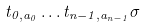Convert formula to latex. <formula><loc_0><loc_0><loc_500><loc_500>t _ { 0 , a _ { 0 } } \dots t _ { n - 1 , a _ { n - 1 } } \sigma</formula> 